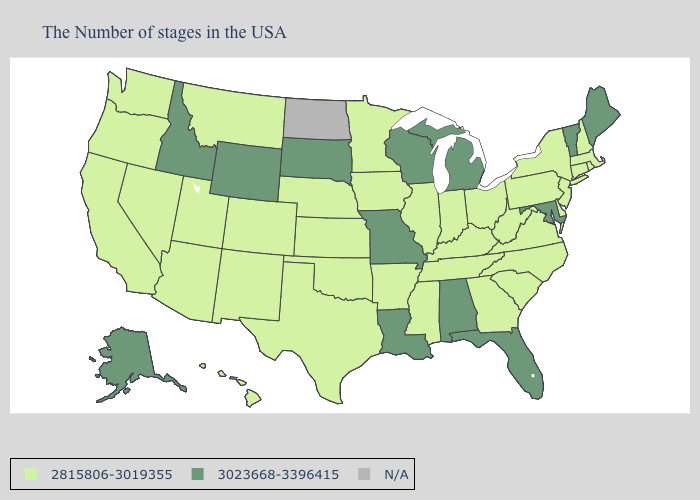Which states hav the highest value in the West?
Be succinct. Wyoming, Idaho, Alaska. What is the lowest value in states that border Utah?
Quick response, please. 2815806-3019355. What is the value of Mississippi?
Be succinct. 2815806-3019355. Does Rhode Island have the highest value in the USA?
Concise answer only. No. Name the states that have a value in the range 2815806-3019355?
Be succinct. Massachusetts, Rhode Island, New Hampshire, Connecticut, New York, New Jersey, Delaware, Pennsylvania, Virginia, North Carolina, South Carolina, West Virginia, Ohio, Georgia, Kentucky, Indiana, Tennessee, Illinois, Mississippi, Arkansas, Minnesota, Iowa, Kansas, Nebraska, Oklahoma, Texas, Colorado, New Mexico, Utah, Montana, Arizona, Nevada, California, Washington, Oregon, Hawaii. Does Nevada have the highest value in the West?
Short answer required. No. Which states have the lowest value in the West?
Concise answer only. Colorado, New Mexico, Utah, Montana, Arizona, Nevada, California, Washington, Oregon, Hawaii. What is the lowest value in the USA?
Give a very brief answer. 2815806-3019355. What is the value of Kentucky?
Write a very short answer. 2815806-3019355. Is the legend a continuous bar?
Quick response, please. No. What is the value of Mississippi?
Concise answer only. 2815806-3019355. How many symbols are there in the legend?
Write a very short answer. 3. What is the value of Ohio?
Answer briefly. 2815806-3019355. Among the states that border New Hampshire , does Maine have the lowest value?
Give a very brief answer. No. 